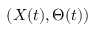<formula> <loc_0><loc_0><loc_500><loc_500>( X ( t ) , \Theta ( t ) )</formula> 